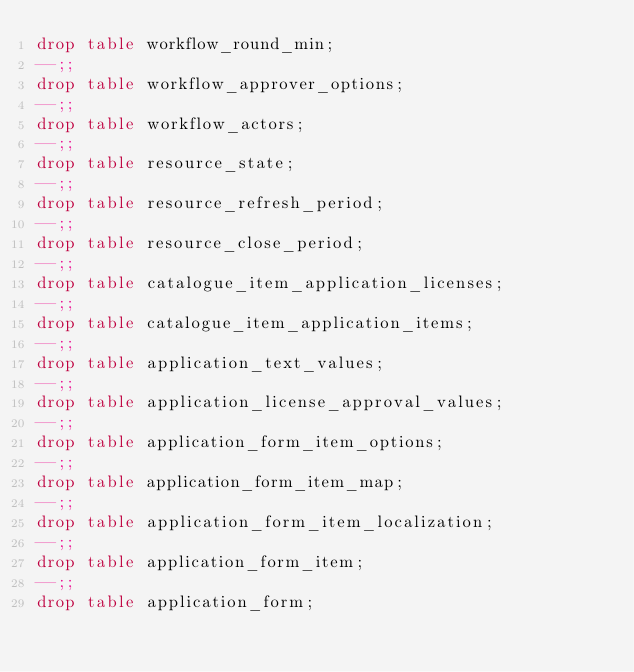Convert code to text. <code><loc_0><loc_0><loc_500><loc_500><_SQL_>drop table workflow_round_min;
--;;
drop table workflow_approver_options;
--;;
drop table workflow_actors;
--;;
drop table resource_state;
--;;
drop table resource_refresh_period;
--;;
drop table resource_close_period;
--;;
drop table catalogue_item_application_licenses;
--;;
drop table catalogue_item_application_items;
--;;
drop table application_text_values;
--;;
drop table application_license_approval_values;
--;;
drop table application_form_item_options;
--;;
drop table application_form_item_map;
--;;
drop table application_form_item_localization;
--;;
drop table application_form_item;
--;;
drop table application_form;
</code> 